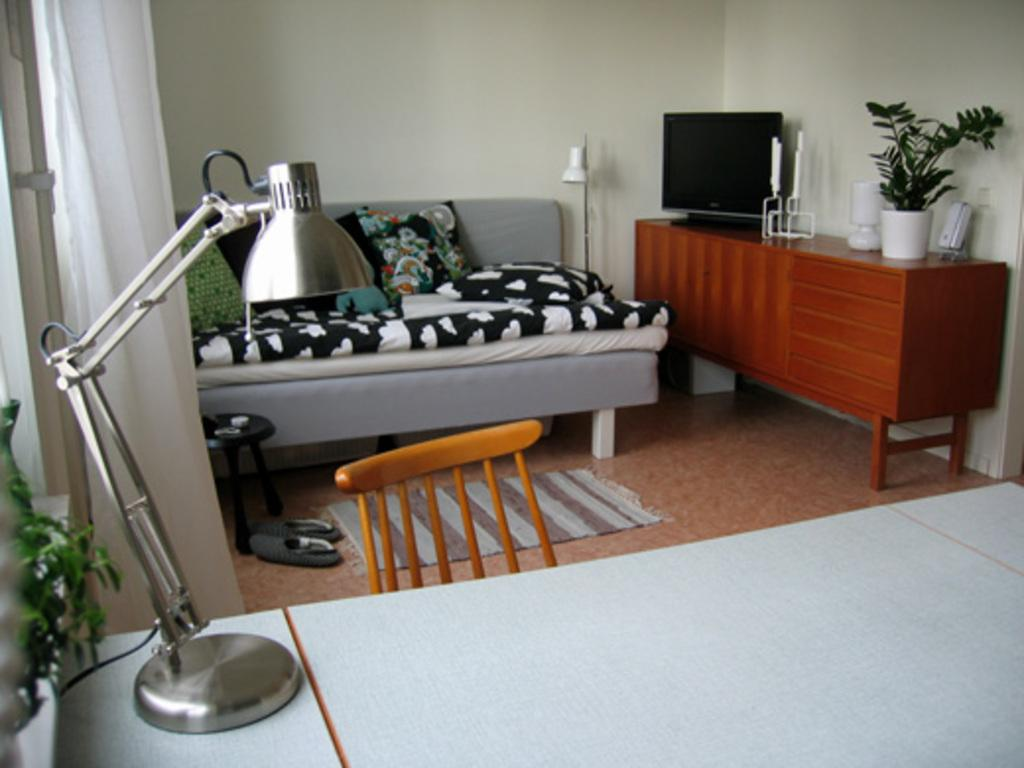What type of furniture is present in the image? There is a couch, a table, and a chair in the image. What is the purpose of the lamp in the image? The lamp in the image provides light. What can be found on the floor in the image? There are shoes in the image. What type of decorative item is present in the image? There is a flower vase in the image. How many sisters are sitting on the couch in the image? There are no sisters present in the image; only furniture and objects are visible. 